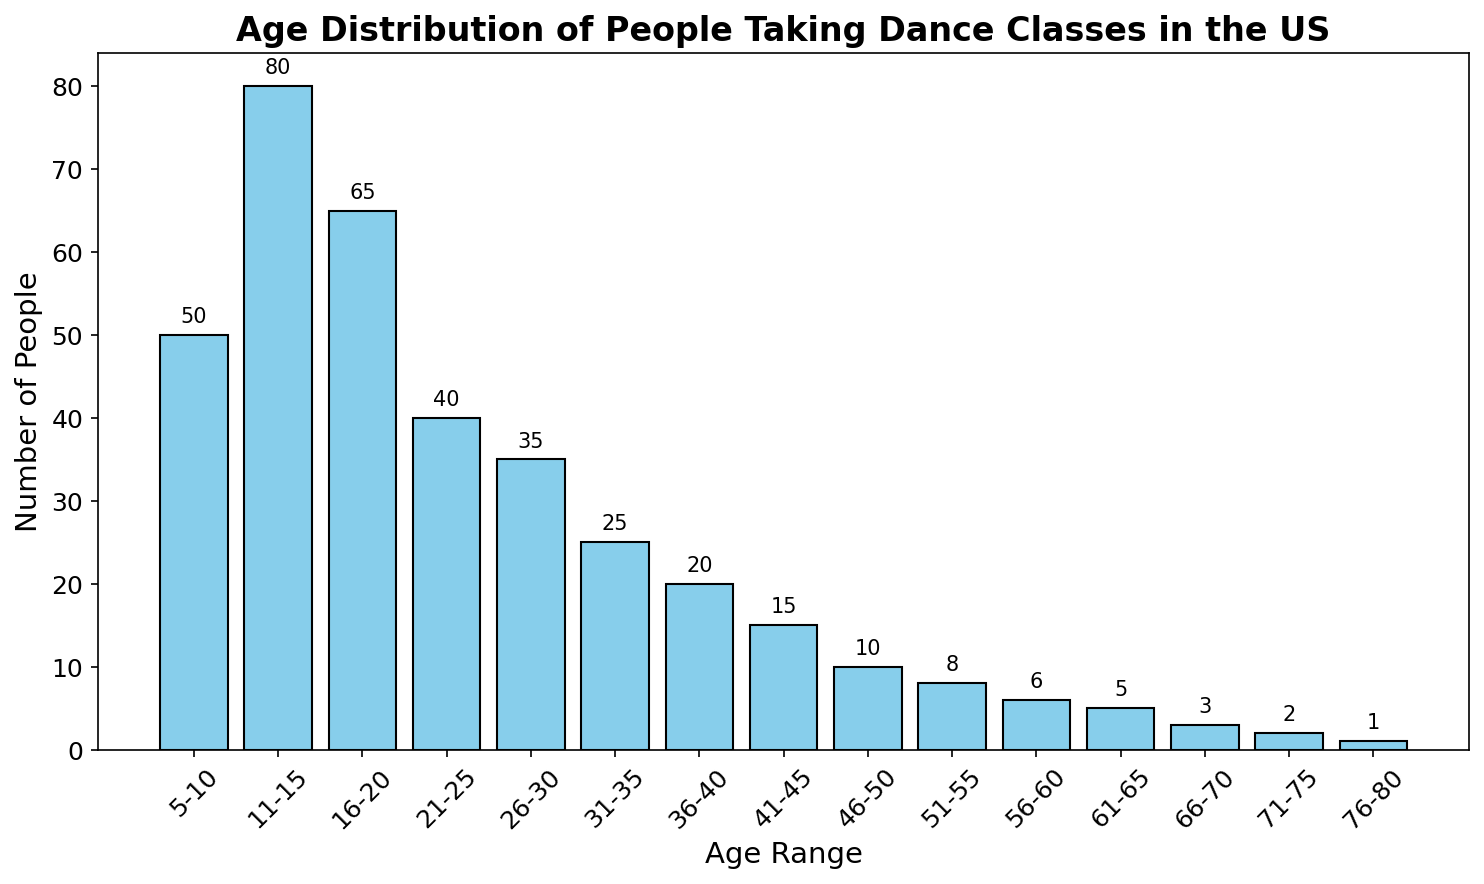What's the age range with the highest number of people taking dance classes? First, scan the x-axis to locate the age ranges. Then, observe the y-axis heights of the bars. The tallest bar corresponds to the age range 11-15.
Answer: 11-15 Which age ranges have fewer than 10 people taking dance classes? Inspect the height of each bar on the y-axis and look for bars whose height is less than 10. These are 46-50, 51-55, 56-60, 61-65, 66-70, 71-75, and 76-80.
Answer: 46-50, 51-55, 56-60, 61-65, 66-70, 71-75, 76-80 What is the total number of people taking dance classes aged 21-25 and 26-30? Check the height of the bars for the age ranges 21-25 and 26-30. The counts are 40 and 35 respectively. Adding these gives 40 + 35 = 75.
Answer: 75 How many more people are taking dance classes in the age range 11-15 than in the age range 5-10? Identify the counts for the age ranges 11-15 and 5-10, which are 80 and 50 respectively. Calculate the difference: 80 - 50 = 30.
Answer: 30 Which age range has exactly 20 people taking dance classes? Locate the bar with a height of 20 on the y-axis, which corresponds to the age range 36-40.
Answer: 36-40 Add up the number of people taking dance classes from age ranges 66-70, 71-75, and 76-80. Identify the counts for the age ranges 66-70, 71-75, and 76-80, which are 3, 2, and 1 respectively. Adding these gives 3 + 2 + 1 = 6.
Answer: 6 Compare the number of people taking dance classes in the age range 16-20 with that in the age range 21-25. Which range has more people, and by how much? The age range 16-20 has a count of 65, and 21-25 has a count of 40. Subtract 40 from 65 to get the difference: 65 - 40 = 25. The age range 16-20 has more people by 25.
Answer: 16-20, 25 What is the sum of the number of people taking dance classes in the age ranges from 36-40 to 56-60? Identify the counts for each age range: 36-40 (20), 41-45 (15), 46-50 (10), 51-55 (8), and 56-60 (6). Add these: 20 + 15 + 10 + 8 + 6 = 59.
Answer: 59 